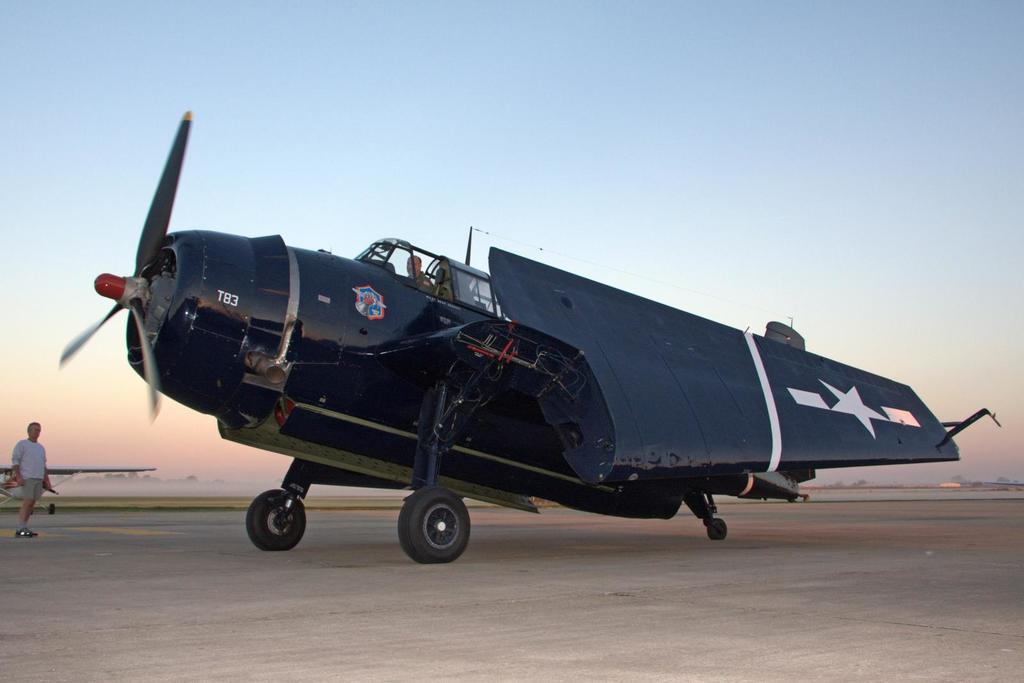<image>
Describe the image concisely. A black propeller type airplane with a T83 on the side is sitting on the runway. 